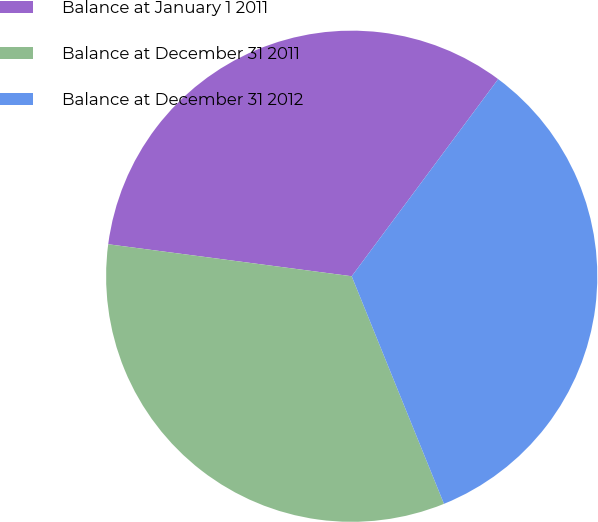Convert chart to OTSL. <chart><loc_0><loc_0><loc_500><loc_500><pie_chart><fcel>Balance at January 1 2011<fcel>Balance at December 31 2011<fcel>Balance at December 31 2012<nl><fcel>33.09%<fcel>33.21%<fcel>33.7%<nl></chart> 